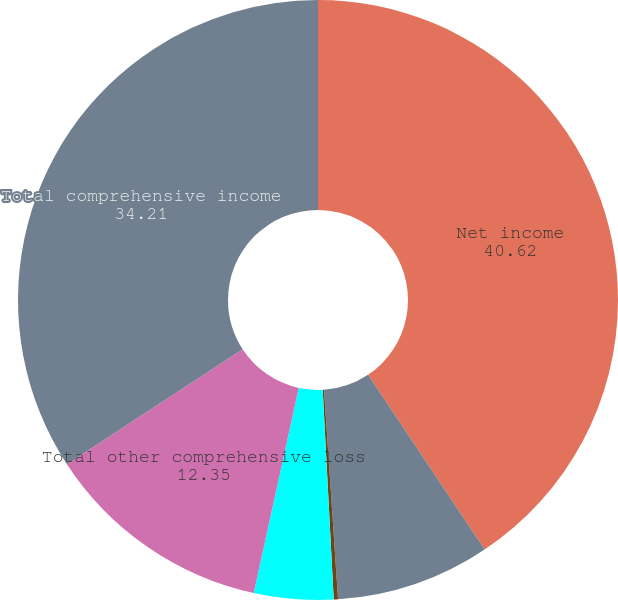Convert chart to OTSL. <chart><loc_0><loc_0><loc_500><loc_500><pie_chart><fcel>Net income<fcel>Foreign currency translation<fcel>Net change in unrecognized<fcel>Net change in unrealized<fcel>Total other comprehensive loss<fcel>Total comprehensive income<nl><fcel>40.62%<fcel>8.31%<fcel>0.23%<fcel>4.27%<fcel>12.35%<fcel>34.21%<nl></chart> 